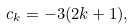Convert formula to latex. <formula><loc_0><loc_0><loc_500><loc_500>c _ { k } = - 3 ( 2 k + 1 ) ,</formula> 